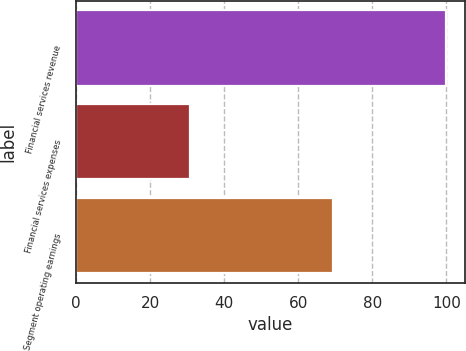Convert chart. <chart><loc_0><loc_0><loc_500><loc_500><bar_chart><fcel>Financial services revenue<fcel>Financial services expenses<fcel>Segment operating earnings<nl><fcel>100<fcel>30.6<fcel>69.4<nl></chart> 